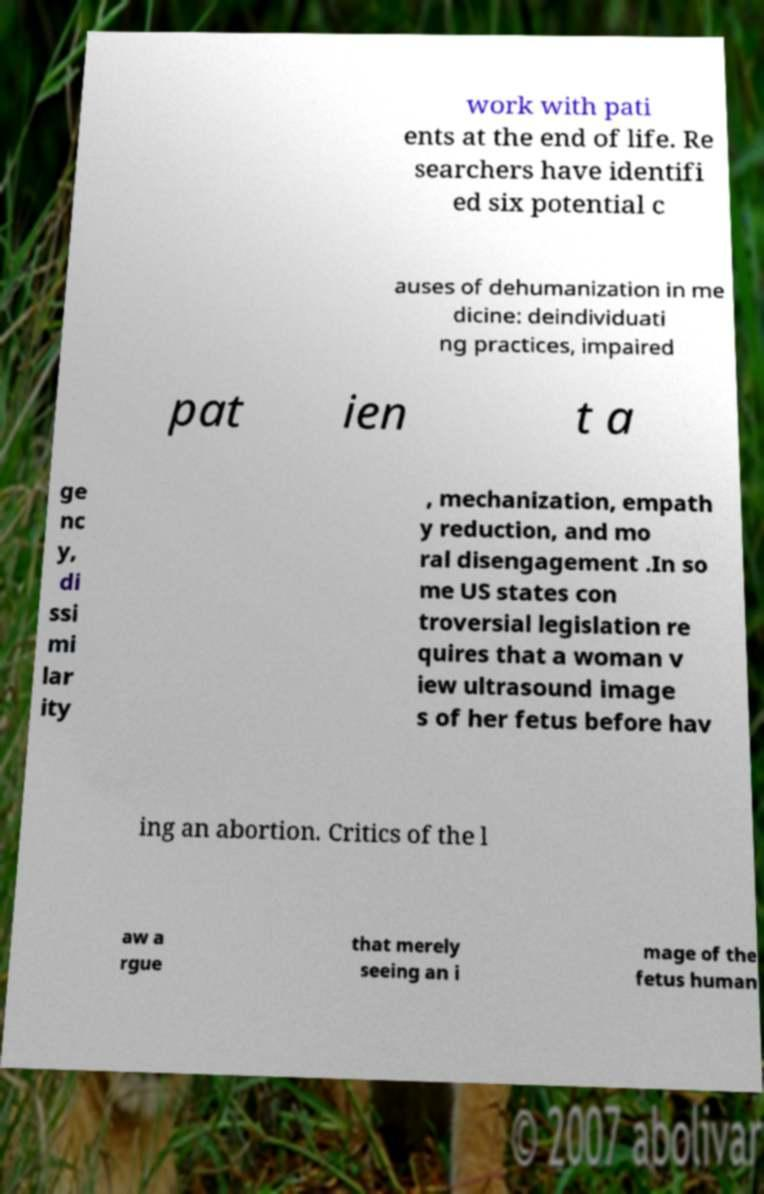Could you extract and type out the text from this image? work with pati ents at the end of life. Re searchers have identifi ed six potential c auses of dehumanization in me dicine: deindividuati ng practices, impaired pat ien t a ge nc y, di ssi mi lar ity , mechanization, empath y reduction, and mo ral disengagement .In so me US states con troversial legislation re quires that a woman v iew ultrasound image s of her fetus before hav ing an abortion. Critics of the l aw a rgue that merely seeing an i mage of the fetus human 